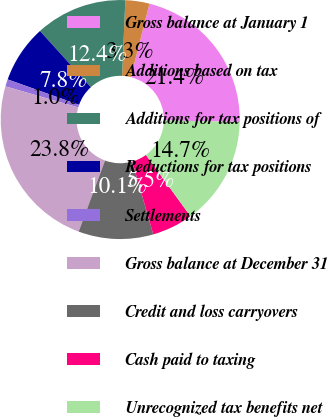Convert chart. <chart><loc_0><loc_0><loc_500><loc_500><pie_chart><fcel>Gross balance at January 1<fcel>Additions based on tax<fcel>Additions for tax positions of<fcel>Reductions for tax positions<fcel>Settlements<fcel>Gross balance at December 31<fcel>Credit and loss carryovers<fcel>Cash paid to taxing<fcel>Unrecognized tax benefits net<nl><fcel>21.39%<fcel>3.25%<fcel>12.4%<fcel>7.83%<fcel>0.97%<fcel>23.83%<fcel>10.11%<fcel>5.54%<fcel>14.68%<nl></chart> 